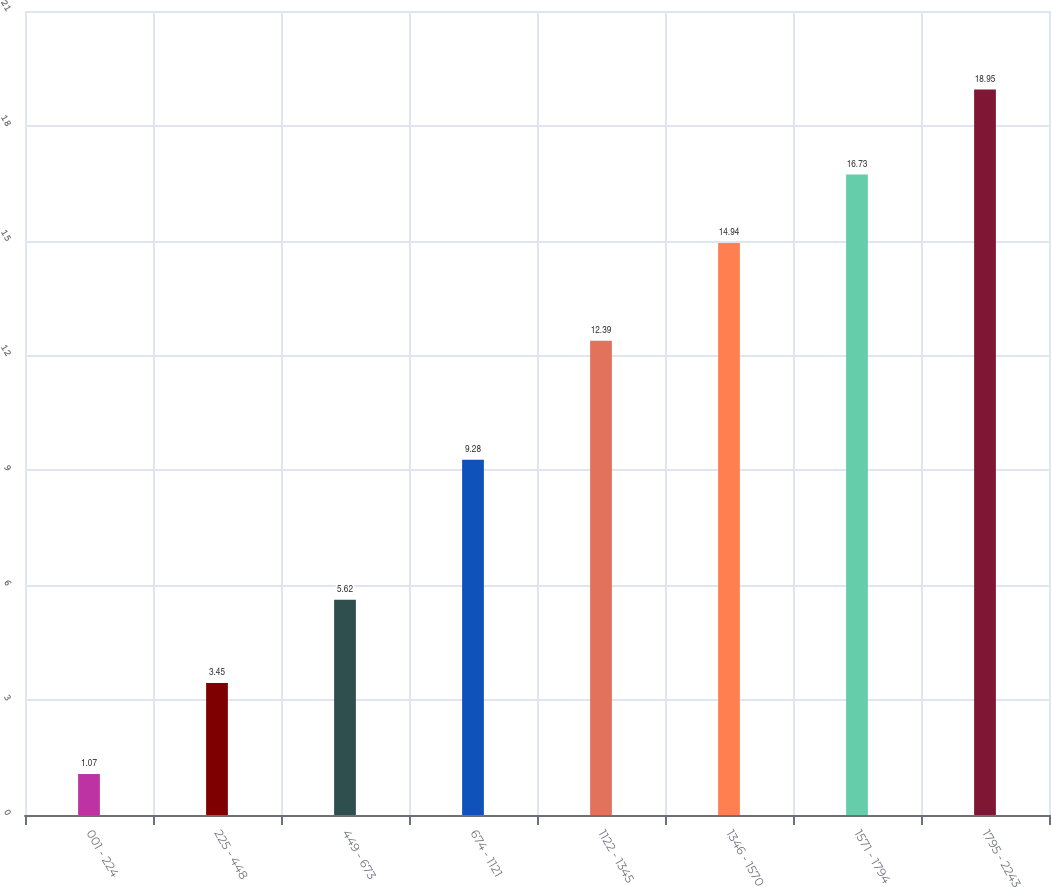<chart> <loc_0><loc_0><loc_500><loc_500><bar_chart><fcel>001 - 224<fcel>225 - 448<fcel>449 - 673<fcel>674 - 1121<fcel>1122 - 1345<fcel>1346 - 1570<fcel>1571 - 1794<fcel>1795 - 2243<nl><fcel>1.07<fcel>3.45<fcel>5.62<fcel>9.28<fcel>12.39<fcel>14.94<fcel>16.73<fcel>18.95<nl></chart> 